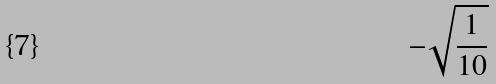<formula> <loc_0><loc_0><loc_500><loc_500>- \sqrt { \frac { 1 } { 1 0 } }</formula> 